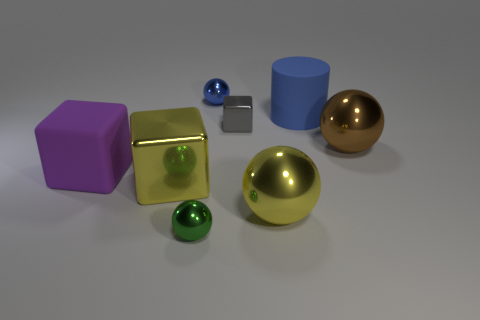How many other objects are the same size as the purple object?
Your answer should be very brief. 4. What is the size of the green metal sphere?
Offer a terse response. Small. Does the large thing that is behind the small block have the same material as the small blue sphere?
Make the answer very short. No. What is the color of the other matte thing that is the same shape as the gray object?
Your answer should be compact. Purple. Does the small metal object behind the blue matte cylinder have the same color as the big rubber cylinder?
Your answer should be very brief. Yes. There is a brown sphere; are there any large blue rubber cylinders to the right of it?
Offer a very short reply. No. There is a large metallic object that is both behind the large yellow metallic sphere and in front of the big brown sphere; what color is it?
Give a very brief answer. Yellow. The small metal thing that is the same color as the big cylinder is what shape?
Make the answer very short. Sphere. There is a cube in front of the matte thing that is on the left side of the yellow cube; what size is it?
Make the answer very short. Large. How many balls are big purple objects or tiny gray shiny things?
Offer a very short reply. 0. 